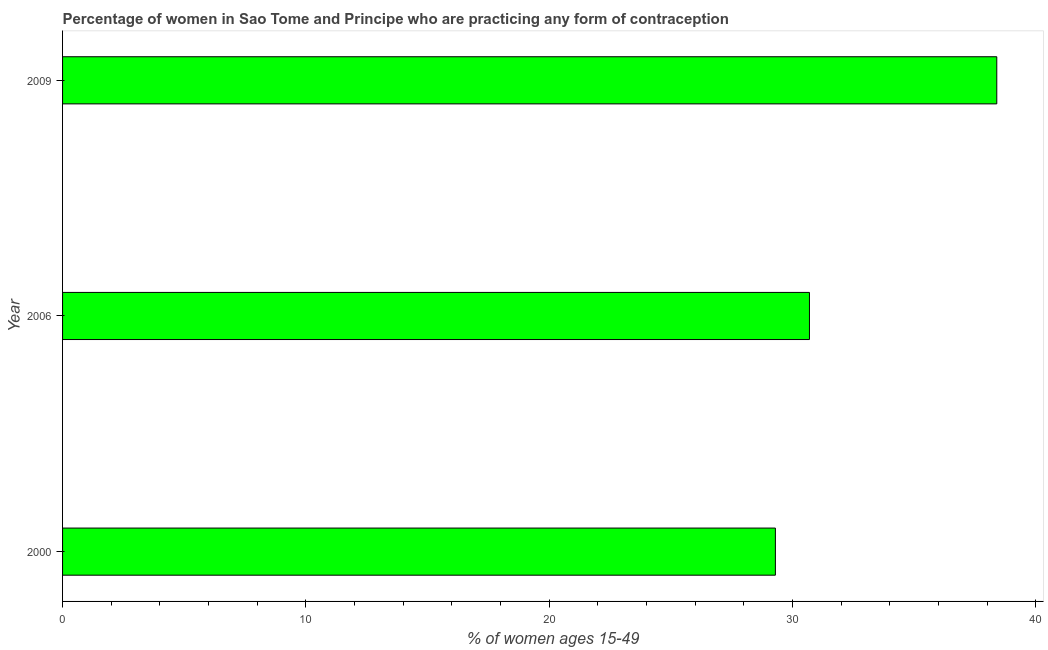Does the graph contain grids?
Provide a short and direct response. No. What is the title of the graph?
Your answer should be compact. Percentage of women in Sao Tome and Principe who are practicing any form of contraception. What is the label or title of the X-axis?
Provide a succinct answer. % of women ages 15-49. What is the label or title of the Y-axis?
Ensure brevity in your answer.  Year. What is the contraceptive prevalence in 2000?
Your answer should be very brief. 29.3. Across all years, what is the maximum contraceptive prevalence?
Give a very brief answer. 38.4. Across all years, what is the minimum contraceptive prevalence?
Ensure brevity in your answer.  29.3. What is the sum of the contraceptive prevalence?
Offer a very short reply. 98.4. What is the difference between the contraceptive prevalence in 2006 and 2009?
Provide a succinct answer. -7.7. What is the average contraceptive prevalence per year?
Your answer should be compact. 32.8. What is the median contraceptive prevalence?
Ensure brevity in your answer.  30.7. What is the ratio of the contraceptive prevalence in 2000 to that in 2009?
Ensure brevity in your answer.  0.76. What is the difference between the highest and the second highest contraceptive prevalence?
Keep it short and to the point. 7.7. In how many years, is the contraceptive prevalence greater than the average contraceptive prevalence taken over all years?
Your answer should be very brief. 1. Are all the bars in the graph horizontal?
Make the answer very short. Yes. How many years are there in the graph?
Ensure brevity in your answer.  3. What is the difference between two consecutive major ticks on the X-axis?
Provide a succinct answer. 10. Are the values on the major ticks of X-axis written in scientific E-notation?
Your answer should be compact. No. What is the % of women ages 15-49 in 2000?
Ensure brevity in your answer.  29.3. What is the % of women ages 15-49 in 2006?
Offer a terse response. 30.7. What is the % of women ages 15-49 in 2009?
Provide a short and direct response. 38.4. What is the difference between the % of women ages 15-49 in 2006 and 2009?
Offer a terse response. -7.7. What is the ratio of the % of women ages 15-49 in 2000 to that in 2006?
Your answer should be compact. 0.95. What is the ratio of the % of women ages 15-49 in 2000 to that in 2009?
Ensure brevity in your answer.  0.76. What is the ratio of the % of women ages 15-49 in 2006 to that in 2009?
Your answer should be very brief. 0.8. 